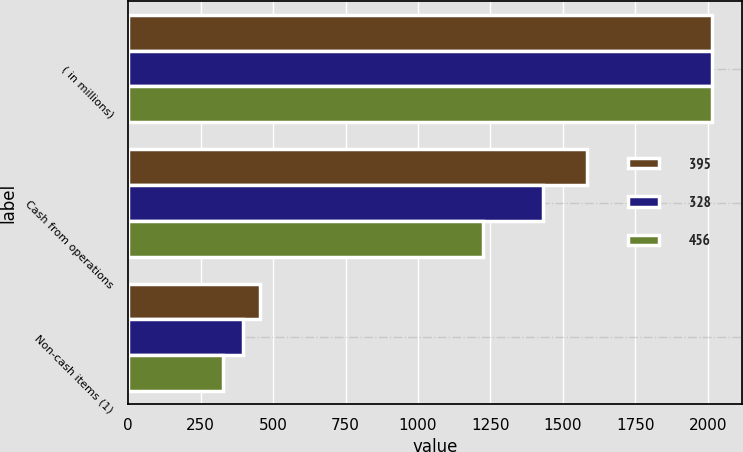Convert chart to OTSL. <chart><loc_0><loc_0><loc_500><loc_500><stacked_bar_chart><ecel><fcel>( in millions)<fcel>Cash from operations<fcel>Non-cash items (1)<nl><fcel>395<fcel>2016<fcel>1582<fcel>456<nl><fcel>328<fcel>2015<fcel>1430<fcel>395<nl><fcel>456<fcel>2014<fcel>1224<fcel>328<nl></chart> 